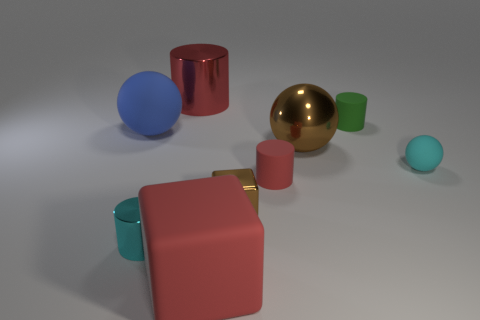There is a tiny cylinder that is the same color as the tiny ball; what is it made of?
Ensure brevity in your answer.  Metal. There is a rubber thing left of the tiny cyan cylinder; is it the same shape as the cyan object that is right of the tiny brown object?
Make the answer very short. Yes. There is a cyan ball that is the same size as the brown metallic block; what is it made of?
Ensure brevity in your answer.  Rubber. Do the block behind the matte block and the cyan object that is right of the big rubber cube have the same material?
Your response must be concise. No. There is a brown object that is the same size as the cyan matte sphere; what is its shape?
Offer a very short reply. Cube. What number of other things are there of the same color as the large metal cylinder?
Provide a short and direct response. 2. What color is the big block in front of the tiny brown metal cube?
Your answer should be very brief. Red. What number of other things are there of the same material as the small brown thing
Make the answer very short. 3. Is the number of cyan rubber objects on the left side of the tiny green cylinder greater than the number of big blue things that are on the right side of the small metallic cylinder?
Ensure brevity in your answer.  No. There is a cyan matte thing; how many big brown objects are on the right side of it?
Offer a very short reply. 0. 